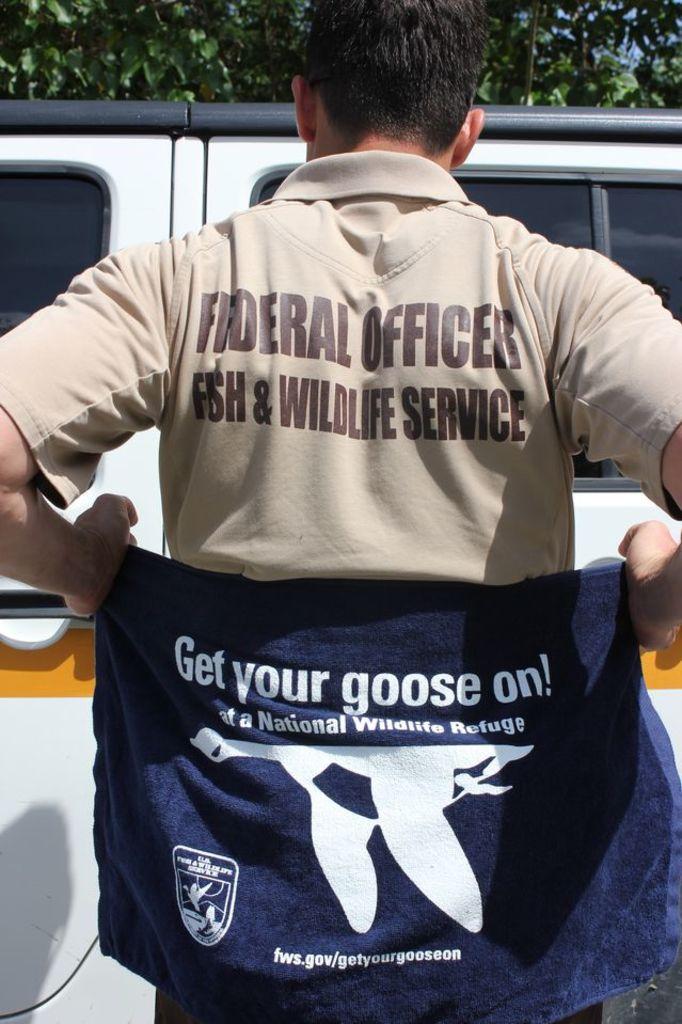Get your goose on is on the top or bottom?
Offer a terse response. Top. 